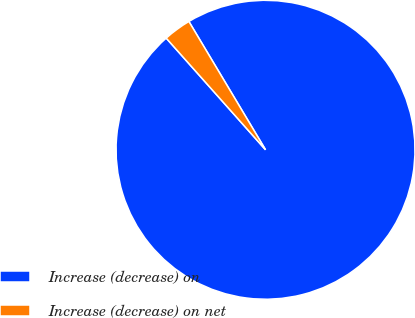<chart> <loc_0><loc_0><loc_500><loc_500><pie_chart><fcel>Increase (decrease) on<fcel>Increase (decrease) on net<nl><fcel>97.0%<fcel>3.0%<nl></chart> 